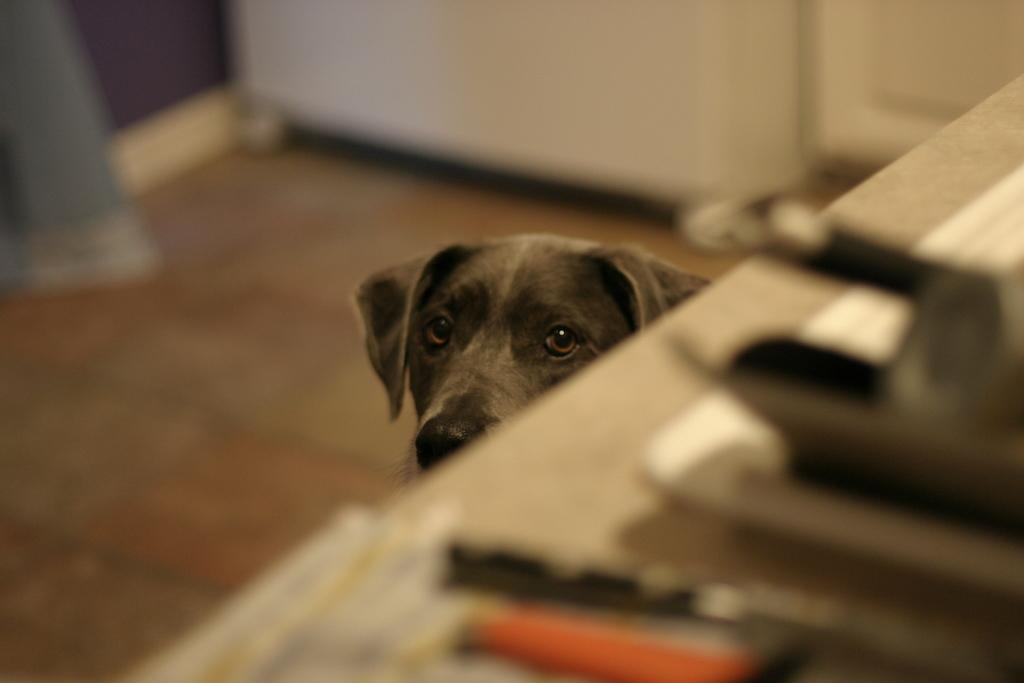What type of animal is in the image? There is a dog in the image. What color is the dog? The dog is black in color. What else can be seen in the image besides the dog? There is a table with objects in the image. Can you describe the background of the image? The background of the image appears blurry. Can you see any visible veins on the dog in the image? There are no visible veins on the dog in the image, as it is not a living creature but a representation, such as a drawing or photograph. What line of work does the dog in the image specialize in? The dog in the image is not a real, living creature, so it does not have a line of work or profession. 